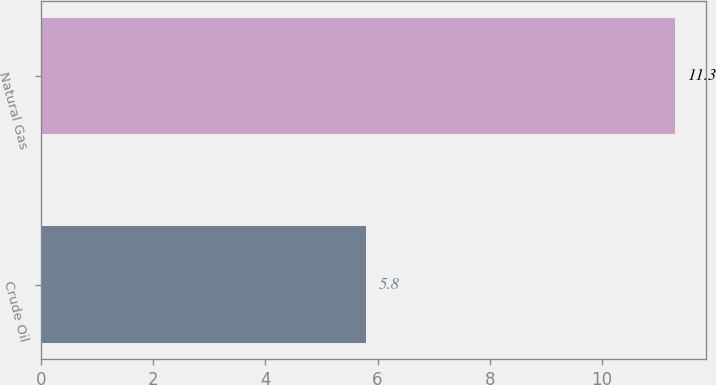<chart> <loc_0><loc_0><loc_500><loc_500><bar_chart><fcel>Crude Oil<fcel>Natural Gas<nl><fcel>5.8<fcel>11.3<nl></chart> 